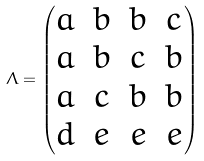<formula> <loc_0><loc_0><loc_500><loc_500>\Lambda = \begin{pmatrix} a & b & b & c \\ a & b & c & b \\ a & c & b & b \\ d & e & e & e \end{pmatrix}</formula> 